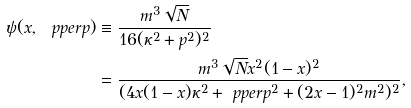Convert formula to latex. <formula><loc_0><loc_0><loc_500><loc_500>\psi ( x , \ p p e r p ) & \equiv \frac { m ^ { 3 } \sqrt { N } } { 1 6 ( \kappa ^ { 2 } + p ^ { 2 } ) ^ { 2 } } \\ & = \frac { m ^ { 3 } \sqrt { N } x ^ { 2 } ( 1 - x ) ^ { 2 } } { ( 4 x ( 1 - x ) \kappa ^ { 2 } + \ p p e r p ^ { 2 } + ( 2 x - 1 ) ^ { 2 } m ^ { 2 } ) ^ { 2 } } ,</formula> 